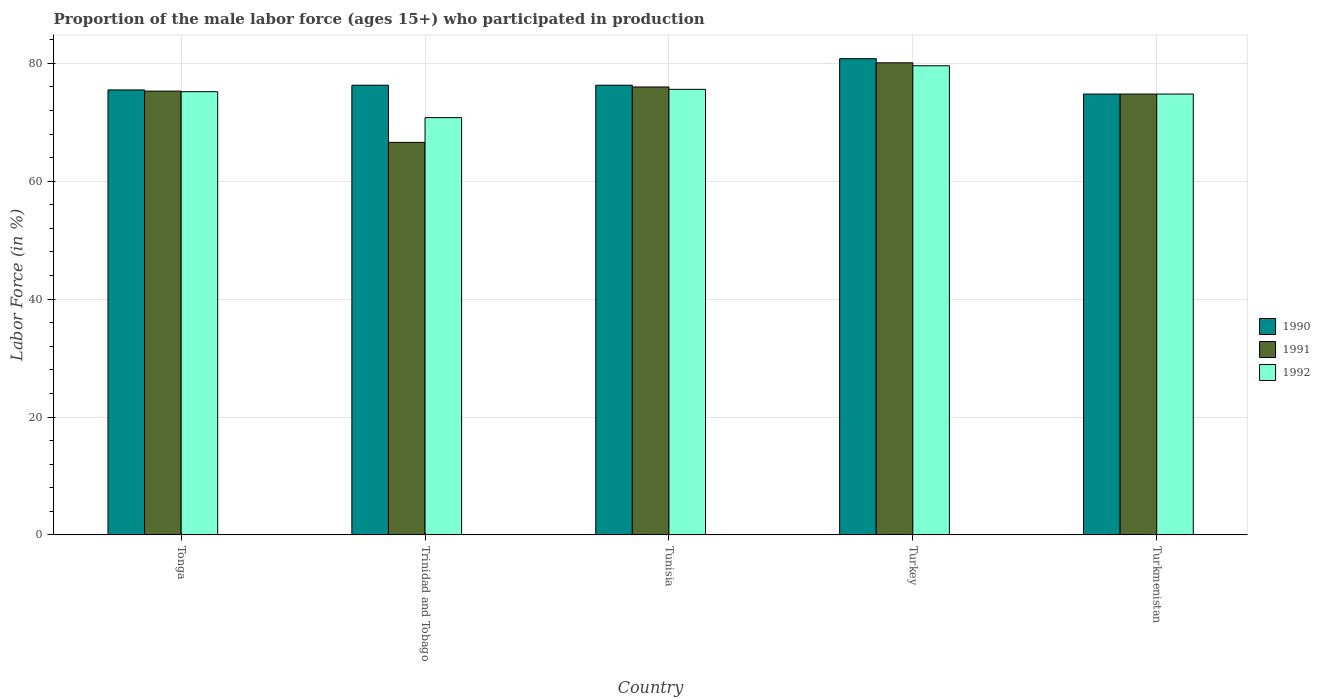How many groups of bars are there?
Give a very brief answer. 5. Are the number of bars on each tick of the X-axis equal?
Keep it short and to the point. Yes. How many bars are there on the 1st tick from the right?
Your response must be concise. 3. What is the label of the 5th group of bars from the left?
Make the answer very short. Turkmenistan. What is the proportion of the male labor force who participated in production in 1990 in Tunisia?
Ensure brevity in your answer.  76.3. Across all countries, what is the maximum proportion of the male labor force who participated in production in 1991?
Your answer should be very brief. 80.1. Across all countries, what is the minimum proportion of the male labor force who participated in production in 1990?
Your answer should be compact. 74.8. In which country was the proportion of the male labor force who participated in production in 1990 maximum?
Give a very brief answer. Turkey. In which country was the proportion of the male labor force who participated in production in 1991 minimum?
Provide a succinct answer. Trinidad and Tobago. What is the total proportion of the male labor force who participated in production in 1990 in the graph?
Provide a short and direct response. 383.7. What is the difference between the proportion of the male labor force who participated in production in 1992 in Trinidad and Tobago and that in Tunisia?
Provide a short and direct response. -4.8. What is the difference between the proportion of the male labor force who participated in production in 1992 in Tonga and the proportion of the male labor force who participated in production in 1991 in Tunisia?
Offer a terse response. -0.8. What is the average proportion of the male labor force who participated in production in 1990 per country?
Your answer should be very brief. 76.74. What is the difference between the proportion of the male labor force who participated in production of/in 1992 and proportion of the male labor force who participated in production of/in 1991 in Trinidad and Tobago?
Ensure brevity in your answer.  4.2. What is the ratio of the proportion of the male labor force who participated in production in 1990 in Tonga to that in Trinidad and Tobago?
Keep it short and to the point. 0.99. Is the difference between the proportion of the male labor force who participated in production in 1992 in Tonga and Trinidad and Tobago greater than the difference between the proportion of the male labor force who participated in production in 1991 in Tonga and Trinidad and Tobago?
Keep it short and to the point. No. What is the difference between the highest and the second highest proportion of the male labor force who participated in production in 1992?
Make the answer very short. -0.4. What is the difference between the highest and the lowest proportion of the male labor force who participated in production in 1991?
Give a very brief answer. 13.5. What does the 1st bar from the left in Trinidad and Tobago represents?
Your response must be concise. 1990. What does the 2nd bar from the right in Turkey represents?
Offer a terse response. 1991. Is it the case that in every country, the sum of the proportion of the male labor force who participated in production in 1992 and proportion of the male labor force who participated in production in 1990 is greater than the proportion of the male labor force who participated in production in 1991?
Offer a terse response. Yes. How many bars are there?
Keep it short and to the point. 15. How many legend labels are there?
Your answer should be very brief. 3. How are the legend labels stacked?
Keep it short and to the point. Vertical. What is the title of the graph?
Give a very brief answer. Proportion of the male labor force (ages 15+) who participated in production. Does "1996" appear as one of the legend labels in the graph?
Offer a very short reply. No. What is the Labor Force (in %) in 1990 in Tonga?
Your answer should be compact. 75.5. What is the Labor Force (in %) of 1991 in Tonga?
Your response must be concise. 75.3. What is the Labor Force (in %) in 1992 in Tonga?
Make the answer very short. 75.2. What is the Labor Force (in %) of 1990 in Trinidad and Tobago?
Give a very brief answer. 76.3. What is the Labor Force (in %) in 1991 in Trinidad and Tobago?
Offer a very short reply. 66.6. What is the Labor Force (in %) of 1992 in Trinidad and Tobago?
Your answer should be very brief. 70.8. What is the Labor Force (in %) of 1990 in Tunisia?
Your answer should be very brief. 76.3. What is the Labor Force (in %) of 1991 in Tunisia?
Your answer should be compact. 76. What is the Labor Force (in %) of 1992 in Tunisia?
Your answer should be very brief. 75.6. What is the Labor Force (in %) in 1990 in Turkey?
Your answer should be very brief. 80.8. What is the Labor Force (in %) of 1991 in Turkey?
Your answer should be compact. 80.1. What is the Labor Force (in %) in 1992 in Turkey?
Your response must be concise. 79.6. What is the Labor Force (in %) of 1990 in Turkmenistan?
Offer a very short reply. 74.8. What is the Labor Force (in %) in 1991 in Turkmenistan?
Your answer should be compact. 74.8. What is the Labor Force (in %) of 1992 in Turkmenistan?
Give a very brief answer. 74.8. Across all countries, what is the maximum Labor Force (in %) in 1990?
Your answer should be compact. 80.8. Across all countries, what is the maximum Labor Force (in %) of 1991?
Make the answer very short. 80.1. Across all countries, what is the maximum Labor Force (in %) in 1992?
Keep it short and to the point. 79.6. Across all countries, what is the minimum Labor Force (in %) in 1990?
Provide a succinct answer. 74.8. Across all countries, what is the minimum Labor Force (in %) in 1991?
Make the answer very short. 66.6. Across all countries, what is the minimum Labor Force (in %) in 1992?
Make the answer very short. 70.8. What is the total Labor Force (in %) of 1990 in the graph?
Offer a terse response. 383.7. What is the total Labor Force (in %) of 1991 in the graph?
Make the answer very short. 372.8. What is the total Labor Force (in %) in 1992 in the graph?
Give a very brief answer. 376. What is the difference between the Labor Force (in %) in 1991 in Tonga and that in Trinidad and Tobago?
Offer a terse response. 8.7. What is the difference between the Labor Force (in %) of 1992 in Tonga and that in Trinidad and Tobago?
Give a very brief answer. 4.4. What is the difference between the Labor Force (in %) in 1992 in Tonga and that in Tunisia?
Offer a terse response. -0.4. What is the difference between the Labor Force (in %) in 1991 in Tonga and that in Turkey?
Make the answer very short. -4.8. What is the difference between the Labor Force (in %) of 1992 in Trinidad and Tobago and that in Tunisia?
Your answer should be compact. -4.8. What is the difference between the Labor Force (in %) in 1990 in Trinidad and Tobago and that in Turkey?
Ensure brevity in your answer.  -4.5. What is the difference between the Labor Force (in %) in 1990 in Trinidad and Tobago and that in Turkmenistan?
Keep it short and to the point. 1.5. What is the difference between the Labor Force (in %) in 1991 in Trinidad and Tobago and that in Turkmenistan?
Offer a terse response. -8.2. What is the difference between the Labor Force (in %) in 1992 in Trinidad and Tobago and that in Turkmenistan?
Make the answer very short. -4. What is the difference between the Labor Force (in %) in 1990 in Tunisia and that in Turkey?
Your response must be concise. -4.5. What is the difference between the Labor Force (in %) of 1991 in Tunisia and that in Turkmenistan?
Give a very brief answer. 1.2. What is the difference between the Labor Force (in %) in 1991 in Turkey and that in Turkmenistan?
Make the answer very short. 5.3. What is the difference between the Labor Force (in %) of 1992 in Turkey and that in Turkmenistan?
Ensure brevity in your answer.  4.8. What is the difference between the Labor Force (in %) in 1990 in Tonga and the Labor Force (in %) in 1991 in Trinidad and Tobago?
Ensure brevity in your answer.  8.9. What is the difference between the Labor Force (in %) of 1990 in Tonga and the Labor Force (in %) of 1992 in Trinidad and Tobago?
Your answer should be compact. 4.7. What is the difference between the Labor Force (in %) in 1991 in Tonga and the Labor Force (in %) in 1992 in Trinidad and Tobago?
Provide a short and direct response. 4.5. What is the difference between the Labor Force (in %) of 1990 in Tonga and the Labor Force (in %) of 1992 in Turkey?
Offer a very short reply. -4.1. What is the difference between the Labor Force (in %) in 1991 in Tonga and the Labor Force (in %) in 1992 in Turkey?
Make the answer very short. -4.3. What is the difference between the Labor Force (in %) in 1990 in Trinidad and Tobago and the Labor Force (in %) in 1991 in Tunisia?
Offer a very short reply. 0.3. What is the difference between the Labor Force (in %) of 1990 in Trinidad and Tobago and the Labor Force (in %) of 1992 in Tunisia?
Your response must be concise. 0.7. What is the difference between the Labor Force (in %) of 1990 in Trinidad and Tobago and the Labor Force (in %) of 1992 in Turkey?
Give a very brief answer. -3.3. What is the difference between the Labor Force (in %) in 1991 in Trinidad and Tobago and the Labor Force (in %) in 1992 in Turkey?
Provide a succinct answer. -13. What is the difference between the Labor Force (in %) in 1990 in Trinidad and Tobago and the Labor Force (in %) in 1991 in Turkmenistan?
Ensure brevity in your answer.  1.5. What is the difference between the Labor Force (in %) in 1990 in Trinidad and Tobago and the Labor Force (in %) in 1992 in Turkmenistan?
Your answer should be compact. 1.5. What is the difference between the Labor Force (in %) in 1990 in Tunisia and the Labor Force (in %) in 1991 in Turkey?
Your answer should be very brief. -3.8. What is the difference between the Labor Force (in %) of 1990 in Tunisia and the Labor Force (in %) of 1992 in Turkey?
Offer a very short reply. -3.3. What is the difference between the Labor Force (in %) in 1991 in Tunisia and the Labor Force (in %) in 1992 in Turkey?
Make the answer very short. -3.6. What is the difference between the Labor Force (in %) of 1991 in Tunisia and the Labor Force (in %) of 1992 in Turkmenistan?
Give a very brief answer. 1.2. What is the difference between the Labor Force (in %) of 1990 in Turkey and the Labor Force (in %) of 1992 in Turkmenistan?
Offer a terse response. 6. What is the average Labor Force (in %) of 1990 per country?
Keep it short and to the point. 76.74. What is the average Labor Force (in %) in 1991 per country?
Your answer should be very brief. 74.56. What is the average Labor Force (in %) in 1992 per country?
Offer a terse response. 75.2. What is the difference between the Labor Force (in %) in 1990 and Labor Force (in %) in 1991 in Tonga?
Keep it short and to the point. 0.2. What is the difference between the Labor Force (in %) in 1990 and Labor Force (in %) in 1992 in Tonga?
Ensure brevity in your answer.  0.3. What is the difference between the Labor Force (in %) of 1990 and Labor Force (in %) of 1992 in Trinidad and Tobago?
Your answer should be very brief. 5.5. What is the difference between the Labor Force (in %) in 1990 and Labor Force (in %) in 1991 in Tunisia?
Your answer should be very brief. 0.3. What is the difference between the Labor Force (in %) of 1990 and Labor Force (in %) of 1991 in Turkey?
Give a very brief answer. 0.7. What is the difference between the Labor Force (in %) in 1990 and Labor Force (in %) in 1992 in Turkey?
Give a very brief answer. 1.2. What is the difference between the Labor Force (in %) in 1991 and Labor Force (in %) in 1992 in Turkmenistan?
Keep it short and to the point. 0. What is the ratio of the Labor Force (in %) in 1990 in Tonga to that in Trinidad and Tobago?
Make the answer very short. 0.99. What is the ratio of the Labor Force (in %) of 1991 in Tonga to that in Trinidad and Tobago?
Your answer should be very brief. 1.13. What is the ratio of the Labor Force (in %) in 1992 in Tonga to that in Trinidad and Tobago?
Provide a short and direct response. 1.06. What is the ratio of the Labor Force (in %) in 1990 in Tonga to that in Tunisia?
Provide a short and direct response. 0.99. What is the ratio of the Labor Force (in %) of 1991 in Tonga to that in Tunisia?
Your answer should be very brief. 0.99. What is the ratio of the Labor Force (in %) in 1990 in Tonga to that in Turkey?
Provide a short and direct response. 0.93. What is the ratio of the Labor Force (in %) in 1991 in Tonga to that in Turkey?
Your answer should be compact. 0.94. What is the ratio of the Labor Force (in %) in 1992 in Tonga to that in Turkey?
Offer a very short reply. 0.94. What is the ratio of the Labor Force (in %) of 1990 in Tonga to that in Turkmenistan?
Give a very brief answer. 1.01. What is the ratio of the Labor Force (in %) of 1992 in Tonga to that in Turkmenistan?
Ensure brevity in your answer.  1.01. What is the ratio of the Labor Force (in %) in 1991 in Trinidad and Tobago to that in Tunisia?
Give a very brief answer. 0.88. What is the ratio of the Labor Force (in %) of 1992 in Trinidad and Tobago to that in Tunisia?
Ensure brevity in your answer.  0.94. What is the ratio of the Labor Force (in %) in 1990 in Trinidad and Tobago to that in Turkey?
Your answer should be compact. 0.94. What is the ratio of the Labor Force (in %) of 1991 in Trinidad and Tobago to that in Turkey?
Offer a very short reply. 0.83. What is the ratio of the Labor Force (in %) of 1992 in Trinidad and Tobago to that in Turkey?
Offer a very short reply. 0.89. What is the ratio of the Labor Force (in %) in 1990 in Trinidad and Tobago to that in Turkmenistan?
Your answer should be very brief. 1.02. What is the ratio of the Labor Force (in %) of 1991 in Trinidad and Tobago to that in Turkmenistan?
Ensure brevity in your answer.  0.89. What is the ratio of the Labor Force (in %) in 1992 in Trinidad and Tobago to that in Turkmenistan?
Offer a very short reply. 0.95. What is the ratio of the Labor Force (in %) of 1990 in Tunisia to that in Turkey?
Provide a succinct answer. 0.94. What is the ratio of the Labor Force (in %) in 1991 in Tunisia to that in Turkey?
Provide a short and direct response. 0.95. What is the ratio of the Labor Force (in %) of 1992 in Tunisia to that in Turkey?
Offer a very short reply. 0.95. What is the ratio of the Labor Force (in %) in 1990 in Tunisia to that in Turkmenistan?
Make the answer very short. 1.02. What is the ratio of the Labor Force (in %) in 1992 in Tunisia to that in Turkmenistan?
Your answer should be very brief. 1.01. What is the ratio of the Labor Force (in %) in 1990 in Turkey to that in Turkmenistan?
Make the answer very short. 1.08. What is the ratio of the Labor Force (in %) of 1991 in Turkey to that in Turkmenistan?
Give a very brief answer. 1.07. What is the ratio of the Labor Force (in %) in 1992 in Turkey to that in Turkmenistan?
Offer a terse response. 1.06. What is the difference between the highest and the second highest Labor Force (in %) of 1990?
Offer a terse response. 4.5. What is the difference between the highest and the second highest Labor Force (in %) of 1991?
Provide a short and direct response. 4.1. What is the difference between the highest and the lowest Labor Force (in %) in 1990?
Provide a short and direct response. 6. What is the difference between the highest and the lowest Labor Force (in %) of 1992?
Your answer should be very brief. 8.8. 